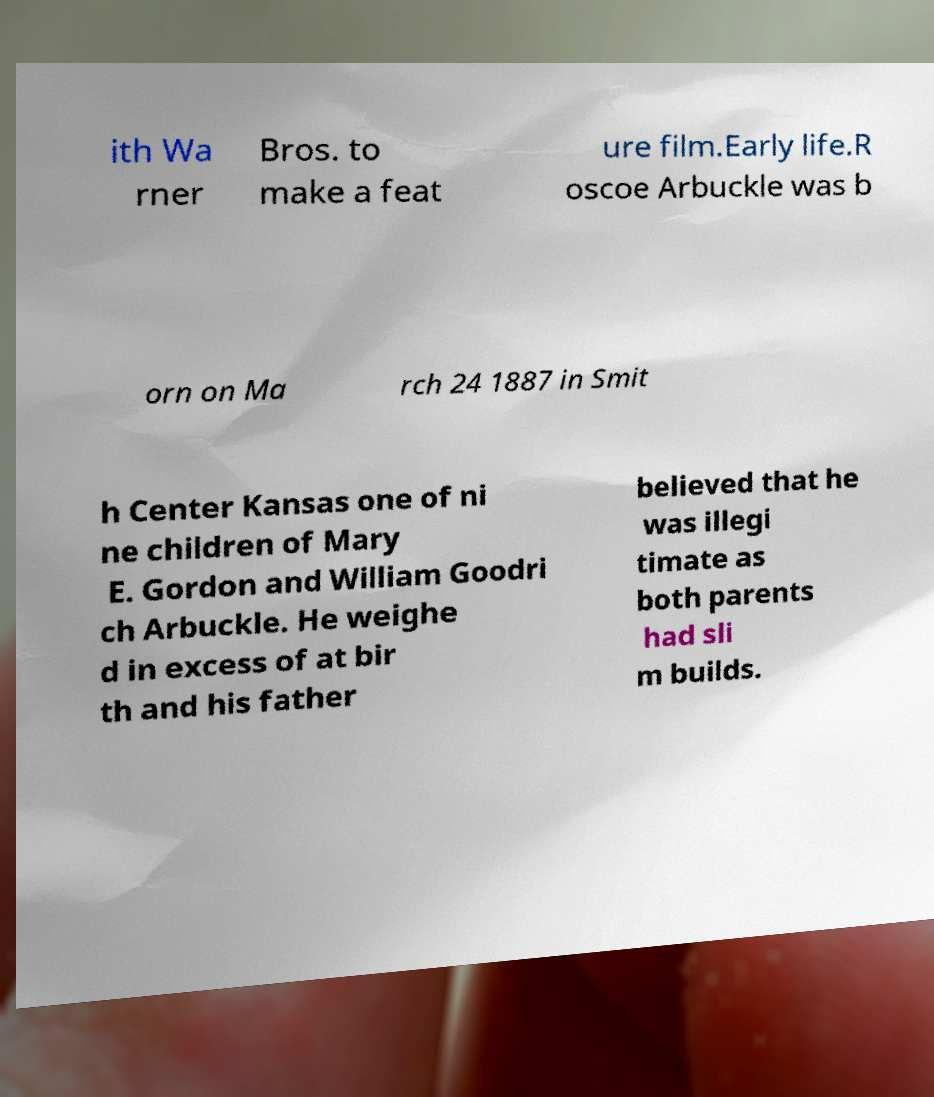Could you assist in decoding the text presented in this image and type it out clearly? ith Wa rner Bros. to make a feat ure film.Early life.R oscoe Arbuckle was b orn on Ma rch 24 1887 in Smit h Center Kansas one of ni ne children of Mary E. Gordon and William Goodri ch Arbuckle. He weighe d in excess of at bir th and his father believed that he was illegi timate as both parents had sli m builds. 